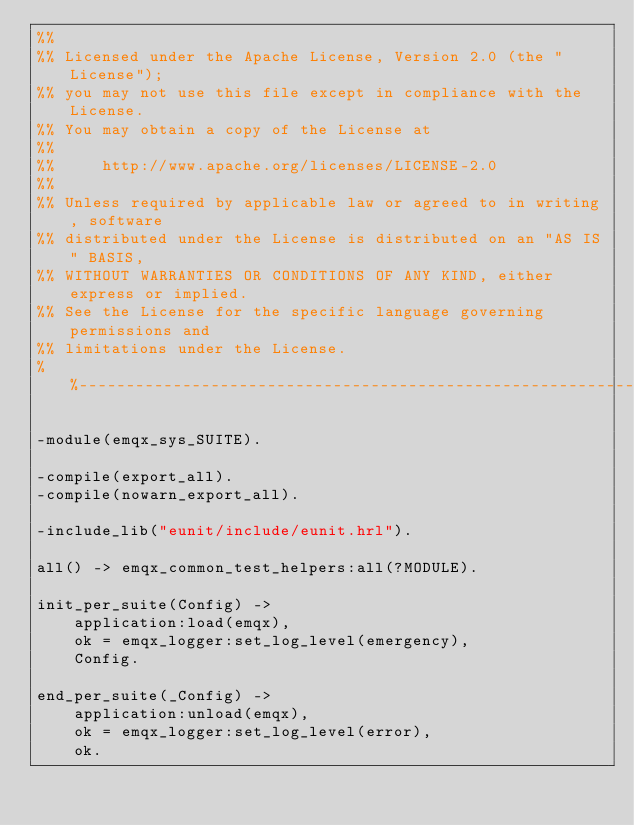<code> <loc_0><loc_0><loc_500><loc_500><_Erlang_>%%
%% Licensed under the Apache License, Version 2.0 (the "License");
%% you may not use this file except in compliance with the License.
%% You may obtain a copy of the License at
%%
%%     http://www.apache.org/licenses/LICENSE-2.0
%%
%% Unless required by applicable law or agreed to in writing, software
%% distributed under the License is distributed on an "AS IS" BASIS,
%% WITHOUT WARRANTIES OR CONDITIONS OF ANY KIND, either express or implied.
%% See the License for the specific language governing permissions and
%% limitations under the License.
%%--------------------------------------------------------------------

-module(emqx_sys_SUITE).

-compile(export_all).
-compile(nowarn_export_all).

-include_lib("eunit/include/eunit.hrl").

all() -> emqx_common_test_helpers:all(?MODULE).

init_per_suite(Config) ->
    application:load(emqx),
    ok = emqx_logger:set_log_level(emergency),
    Config.

end_per_suite(_Config) ->
    application:unload(emqx),
    ok = emqx_logger:set_log_level(error),
    ok.
</code> 